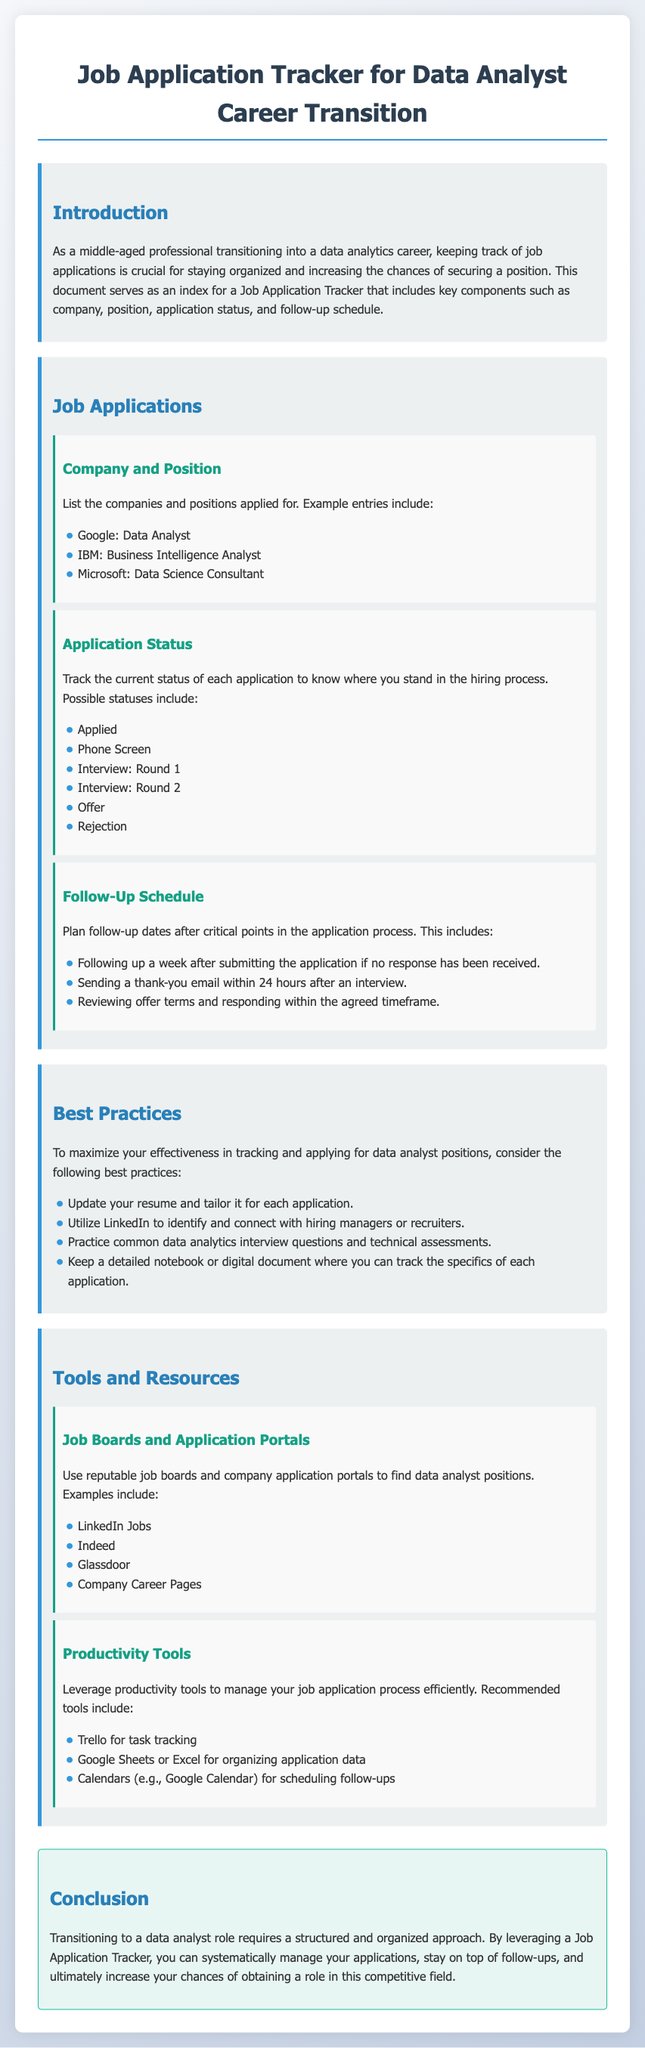What is the title of the document? The title of the document is specified in the <title> tag in the head section of the HTML.
Answer: Job Application Tracker for Data Analyst Career Transition How many companies are listed under Company and Position? The section lists example companies, providing three entries that represent the number of companies.
Answer: 3 What are the possible statuses for job applications? The document provides a list of application statuses, which include multiple options.
Answer: Applied, Phone Screen, Interview: Round 1, Interview: Round 2, Offer, Rejection What should be done after submitting an application if no response has been received? This is mentioned under the Follow-Up Schedule, indicating what action to take in that scenario.
Answer: Following up a week after submitting the application Which tool is recommended for task tracking? The document mentions a productivity tool specifically designed for task management related to job applications.
Answer: Trello What color is the background of the document? The background is described using a gradient color scheme in the CSS style section of the HTML.
Answer: Gradient from light gray to light blue Which platforms are suggested for finding data analyst positions? The Tools and Resources section provides a list of job boards and portals suitable for job searches.
Answer: LinkedIn Jobs, Indeed, Glassdoor, Company Career Pages What is the primary goal of the Job Application Tracker? The conclusion of the document outlines the main purpose and benefit of using the tracker.
Answer: To systematically manage your applications What strategy is suggested to connect with hiring managers? The document indicates a specific action that can increase networking opportunities for job applications.
Answer: Utilize LinkedIn 